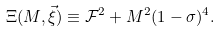<formula> <loc_0><loc_0><loc_500><loc_500>\Xi ( M , \vec { \xi } ) \equiv \mathcal { F } ^ { 2 } + M ^ { 2 } ( 1 - \sigma ) ^ { 4 } .</formula> 